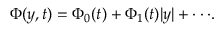Convert formula to latex. <formula><loc_0><loc_0><loc_500><loc_500>\Phi ( y , t ) = \Phi _ { 0 } ( t ) + \Phi _ { 1 } ( t ) | y | + \cdot \cdot \cdot .</formula> 